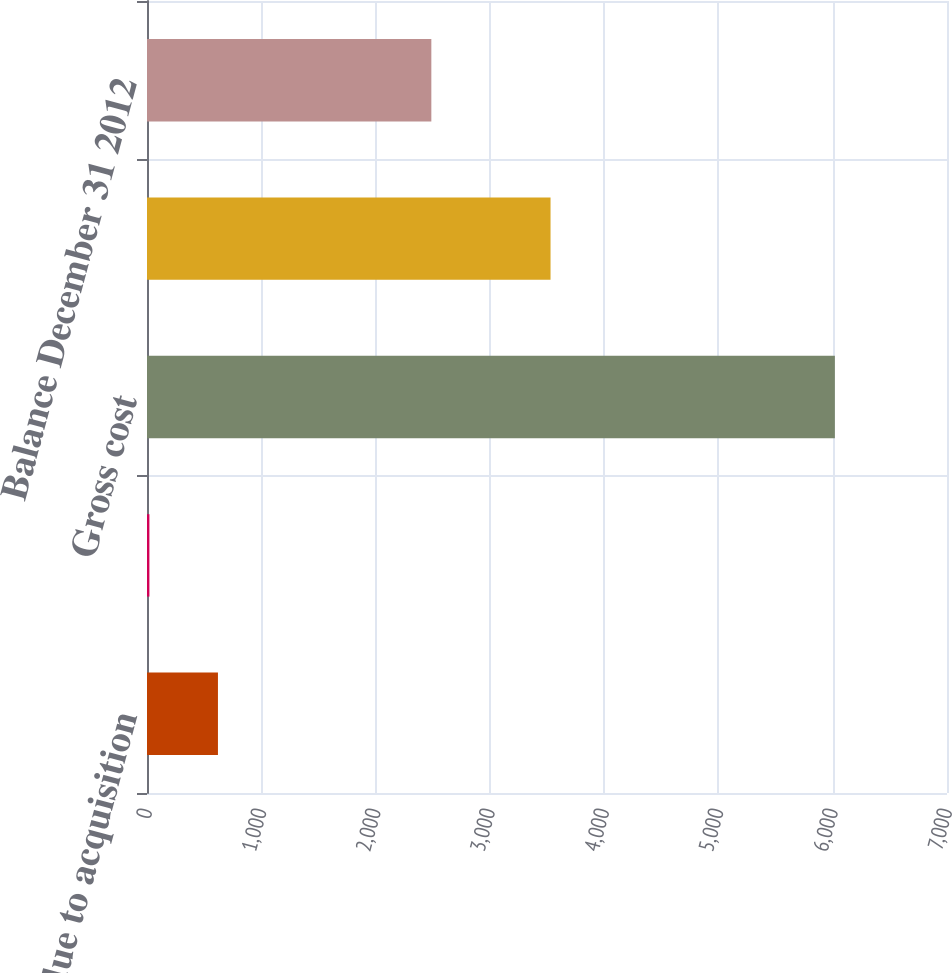Convert chart. <chart><loc_0><loc_0><loc_500><loc_500><bar_chart><fcel>Additions due to acquisition<fcel>Foreign currency translation<fcel>Gross cost<fcel>Accumulated amortization (2)<fcel>Balance December 31 2012<nl><fcel>620.8<fcel>21<fcel>6019<fcel>3531<fcel>2488<nl></chart> 